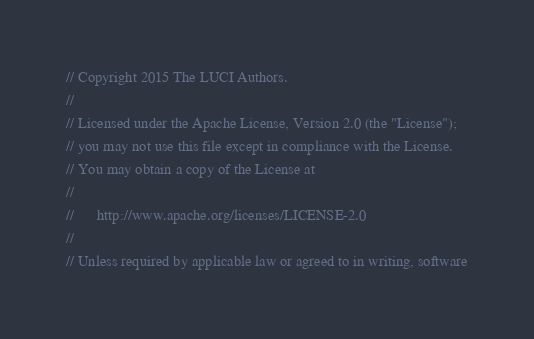<code> <loc_0><loc_0><loc_500><loc_500><_Go_>// Copyright 2015 The LUCI Authors.
//
// Licensed under the Apache License, Version 2.0 (the "License");
// you may not use this file except in compliance with the License.
// You may obtain a copy of the License at
//
//      http://www.apache.org/licenses/LICENSE-2.0
//
// Unless required by applicable law or agreed to in writing, software</code> 